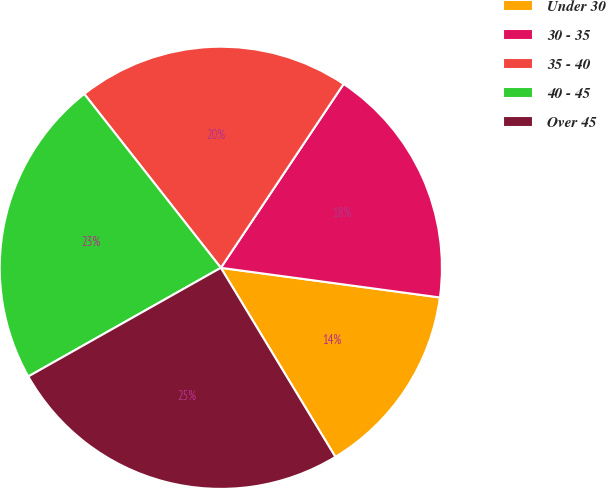Convert chart to OTSL. <chart><loc_0><loc_0><loc_500><loc_500><pie_chart><fcel>Under 30<fcel>30 - 35<fcel>35 - 40<fcel>40 - 45<fcel>Over 45<nl><fcel>14.19%<fcel>17.77%<fcel>19.97%<fcel>22.58%<fcel>25.49%<nl></chart> 